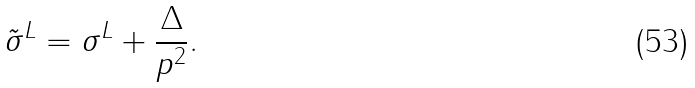<formula> <loc_0><loc_0><loc_500><loc_500>\tilde { \sigma } ^ { L } = \sigma ^ { L } + \frac { \Delta } { p ^ { 2 } } .</formula> 